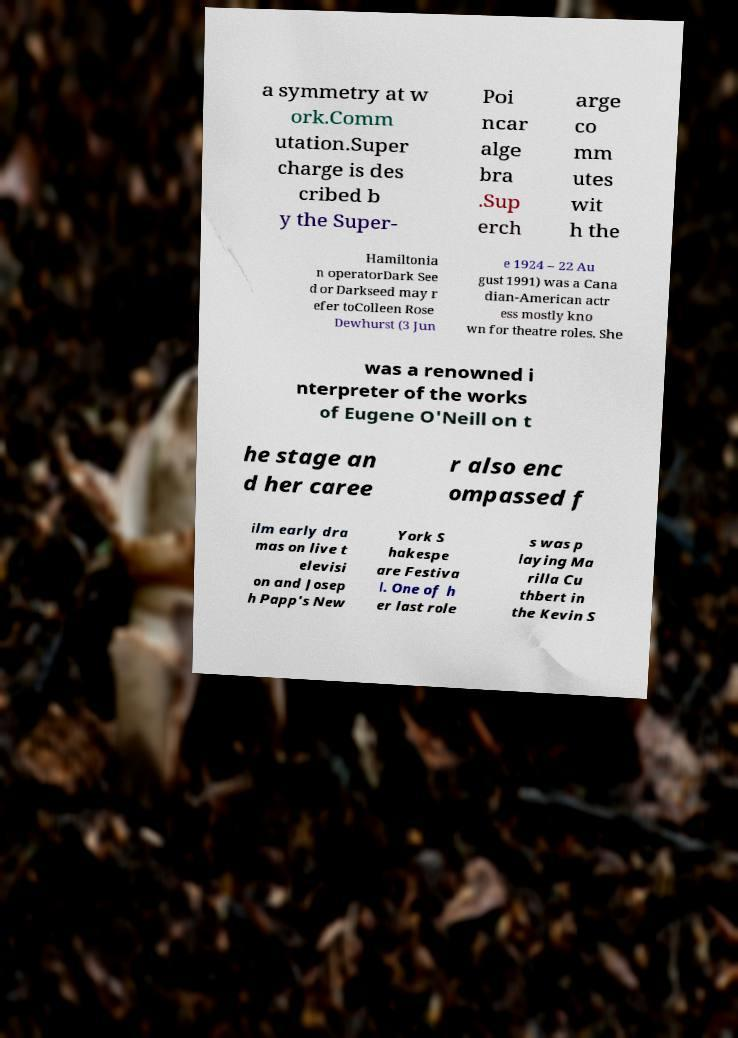Can you read and provide the text displayed in the image?This photo seems to have some interesting text. Can you extract and type it out for me? a symmetry at w ork.Comm utation.Super charge is des cribed b y the Super- Poi ncar alge bra .Sup erch arge co mm utes wit h the Hamiltonia n operatorDark See d or Darkseed may r efer toColleen Rose Dewhurst (3 Jun e 1924 – 22 Au gust 1991) was a Cana dian-American actr ess mostly kno wn for theatre roles. She was a renowned i nterpreter of the works of Eugene O'Neill on t he stage an d her caree r also enc ompassed f ilm early dra mas on live t elevisi on and Josep h Papp's New York S hakespe are Festiva l. One of h er last role s was p laying Ma rilla Cu thbert in the Kevin S 